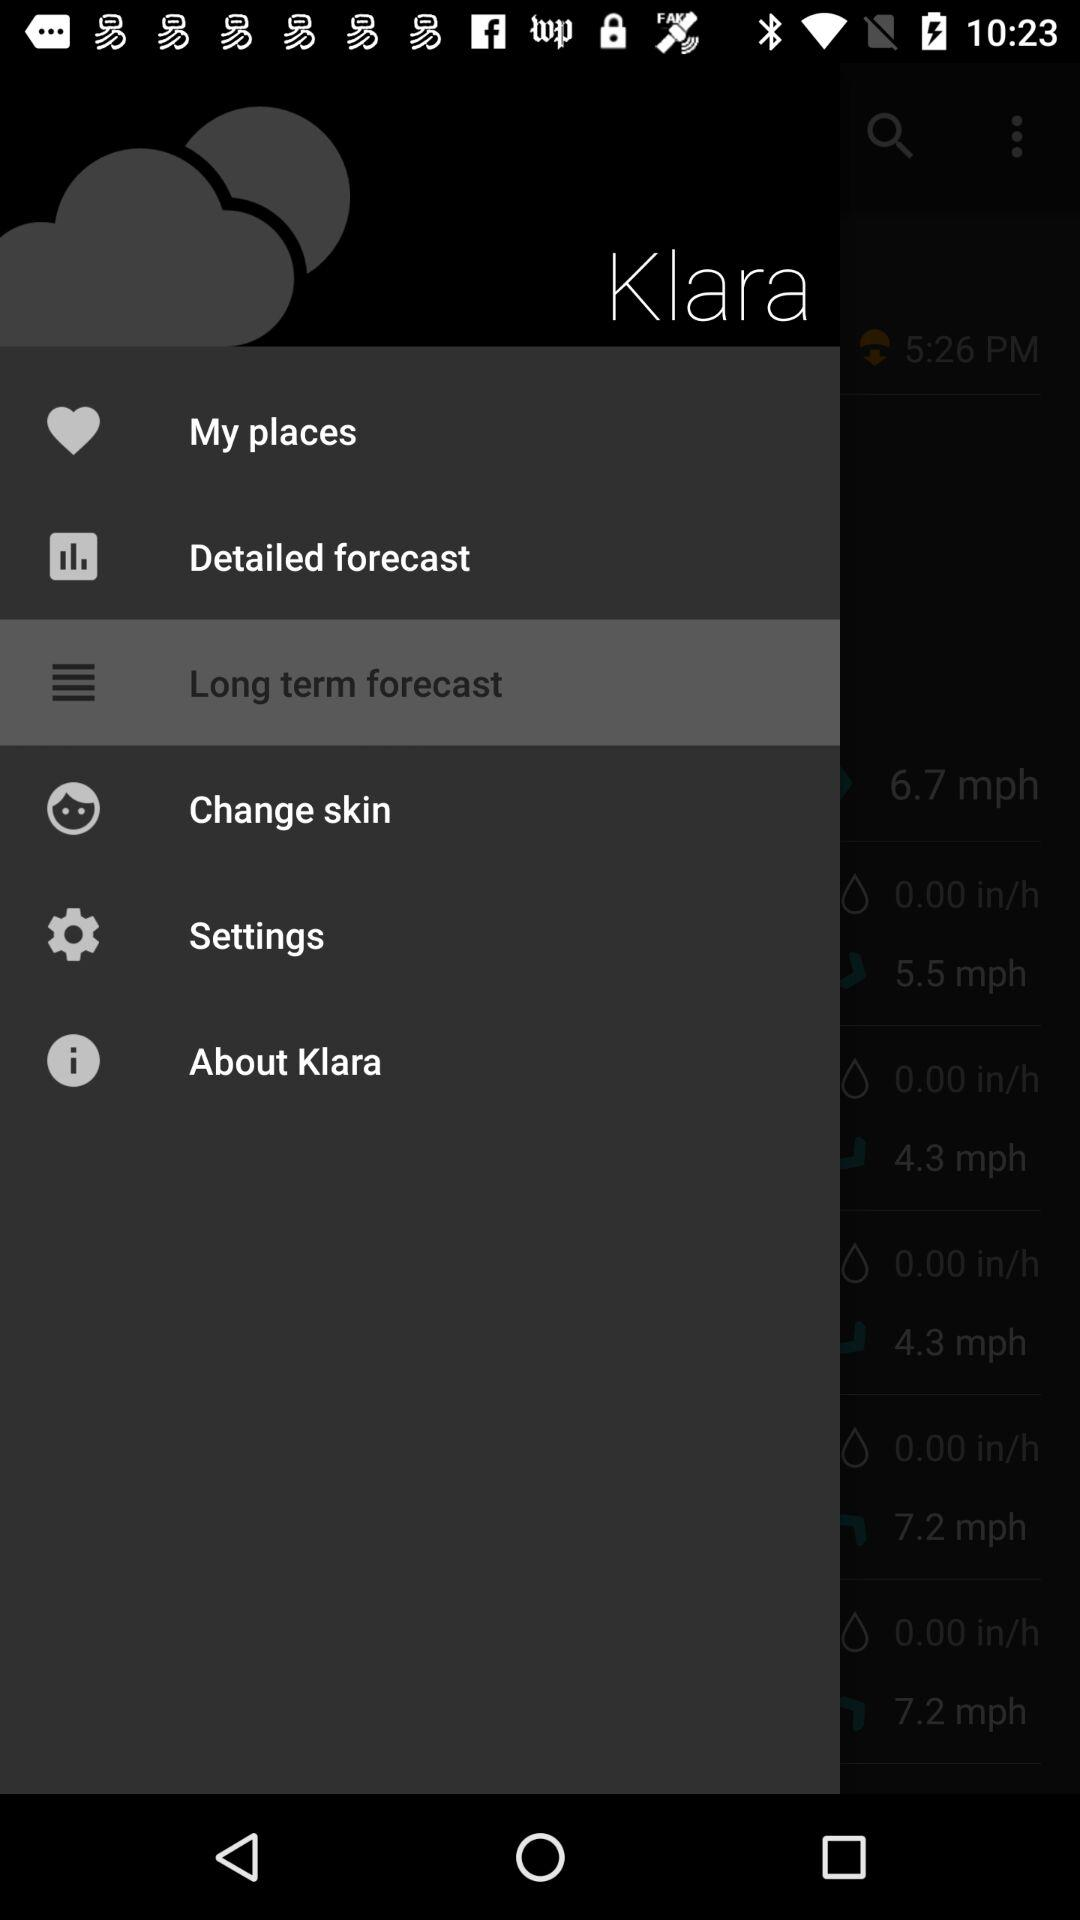What is the application name? the application name is "Klara". 